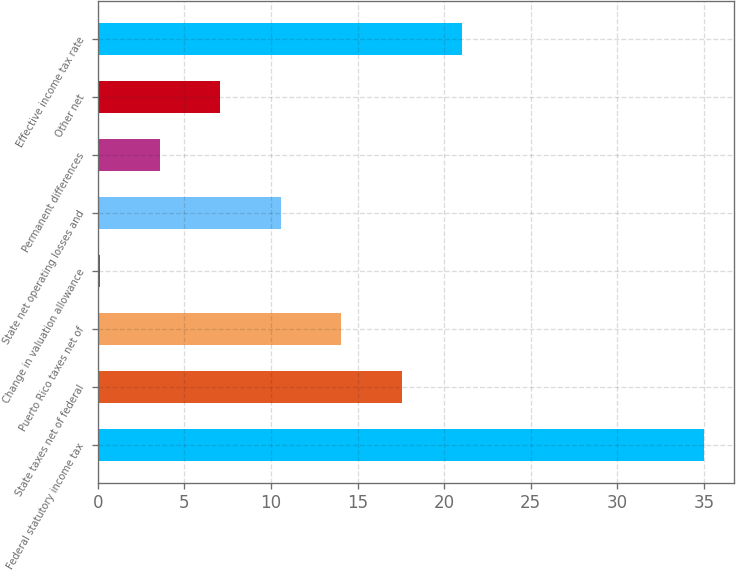<chart> <loc_0><loc_0><loc_500><loc_500><bar_chart><fcel>Federal statutory income tax<fcel>State taxes net of federal<fcel>Puerto Rico taxes net of<fcel>Change in valuation allowance<fcel>State net operating losses and<fcel>Permanent differences<fcel>Other net<fcel>Effective income tax rate<nl><fcel>35<fcel>17.55<fcel>14.06<fcel>0.1<fcel>10.57<fcel>3.59<fcel>7.08<fcel>21.04<nl></chart> 